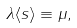Convert formula to latex. <formula><loc_0><loc_0><loc_500><loc_500>\lambda \langle s \rangle \equiv \mu ,</formula> 